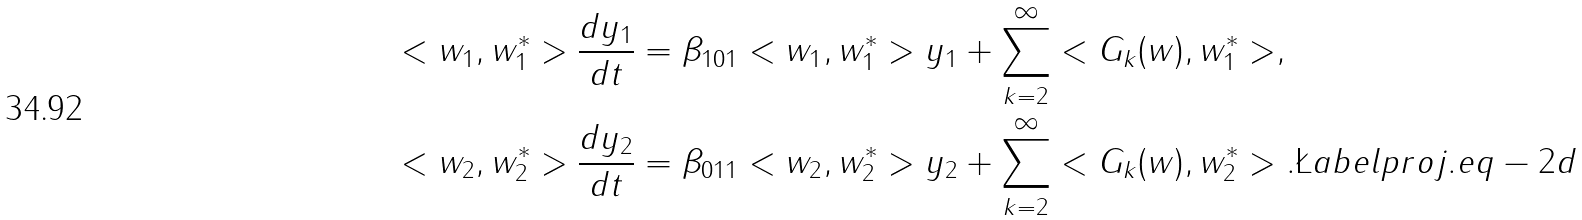<formula> <loc_0><loc_0><loc_500><loc_500>< w _ { 1 } , w _ { 1 } ^ { * } > \frac { d y _ { 1 } } { d t } & = \beta _ { 1 0 1 } < w _ { 1 } , w _ { 1 } ^ { * } > y _ { 1 } + \sum _ { k = 2 } ^ { \infty } < G _ { k } ( w ) , w _ { 1 } ^ { * } > , \\ < w _ { 2 } , w _ { 2 } ^ { * } > \frac { d y _ { 2 } } { d t } & = \beta _ { 0 1 1 } < w _ { 2 } , w _ { 2 } ^ { * } > y _ { 2 } + \sum _ { k = 2 } ^ { \infty } < G _ { k } ( w ) , w _ { 2 } ^ { * } > . \L a b e l { p r o j . e q - 2 d }</formula> 